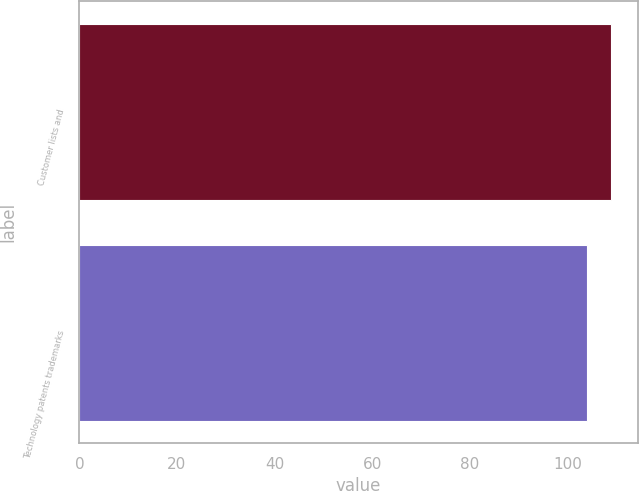Convert chart to OTSL. <chart><loc_0><loc_0><loc_500><loc_500><bar_chart><fcel>Customer lists and<fcel>Technology patents trademarks<nl><fcel>109<fcel>104<nl></chart> 